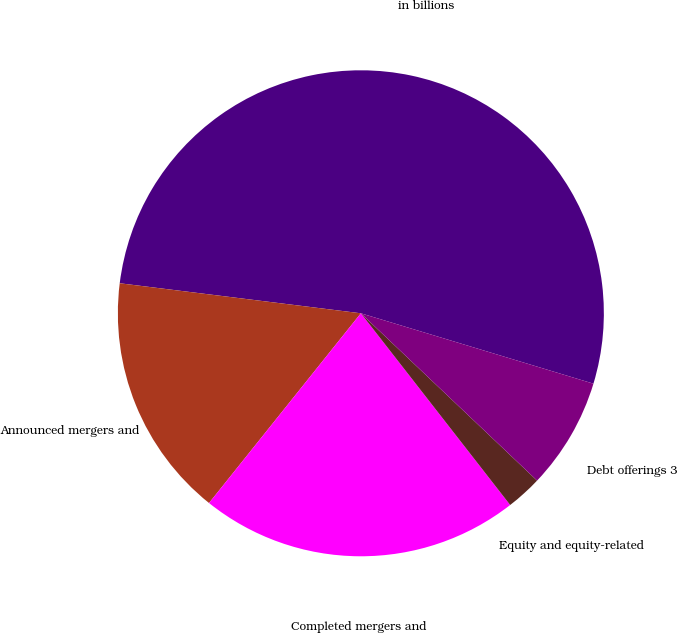<chart> <loc_0><loc_0><loc_500><loc_500><pie_chart><fcel>in billions<fcel>Announced mergers and<fcel>Completed mergers and<fcel>Equity and equity-related<fcel>Debt offerings 3<nl><fcel>52.7%<fcel>16.23%<fcel>21.27%<fcel>2.38%<fcel>7.41%<nl></chart> 